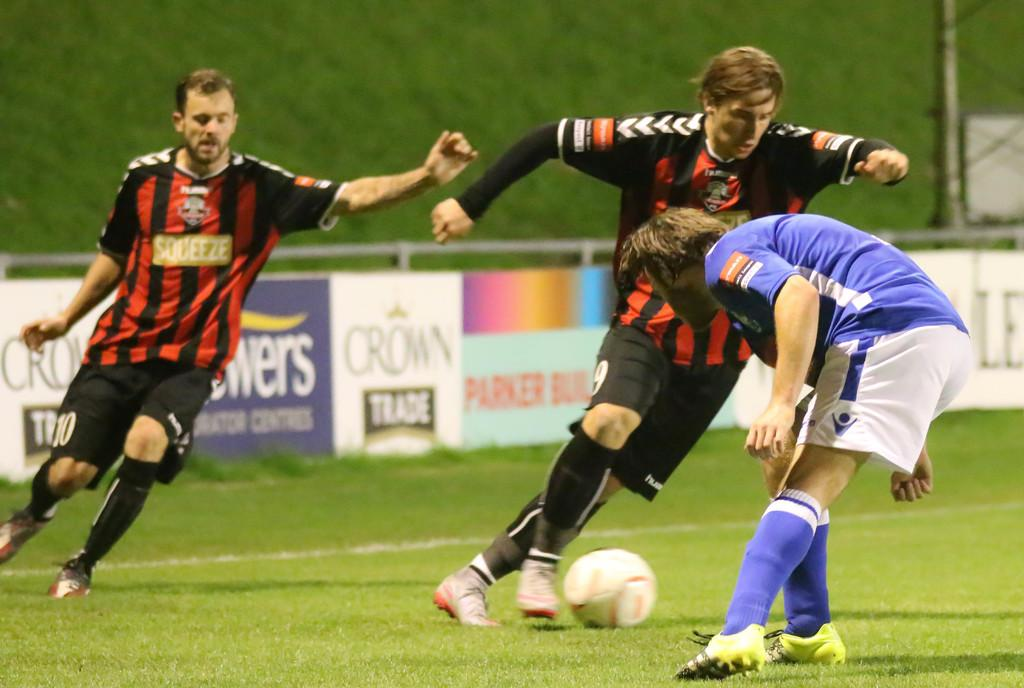What sport are the players engaged in within the image? The players are playing football. Where is the football game taking place? The football game is taking place on a ground. What additional feature can be seen in the image? There is a banner visible in the image. Which direction is the goat facing in the image? There is no goat present in the image. 